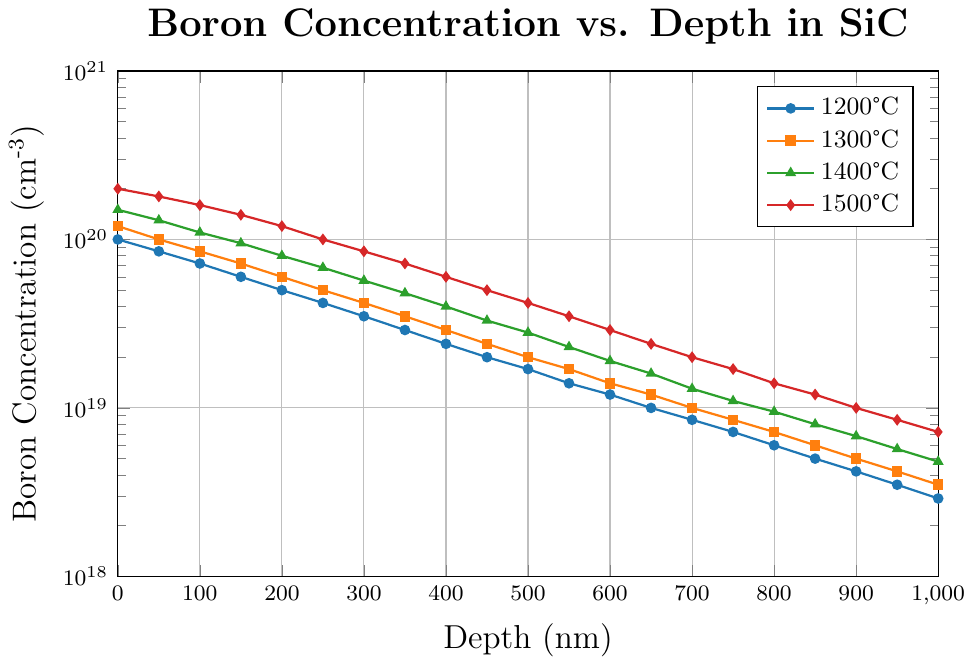What is the Boron concentration at a depth of 400 nm for the annealing temperature of 1500°C? Locate the line corresponding to 1500°C (red color). Find the point on this line at a depth of 400 nm. The Boron concentration at this point is 6.0E+19 cm\textsuperscript{-3}.
Answer: 6.0E+19 cm\textsuperscript{-3} Which annealing temperature shows the highest Boron concentration at a depth of 0 nm? Look at the starting points (depth 0 nm) of all the lines. The red line (1500°C) has the highest starting value of 2.0E+20 cm\textsuperscript{-3}.
Answer: 1500°C What is the rate of decrease in Boron concentration from 0 nm to 100 nm for the temperature 1300°C? Locate the square markers representing 1300°C line. At 0 nm, the concentration is 1.2E+20 cm\textsuperscript{-3} and at 100 nm, it is 8.5E+19 cm\textsuperscript{-3}. The rate of decrease is (1.2E+20 - 8.5E+19 cm\textsuperscript{-3}) / 100 nm.
Answer: 3.5E+18 cm\textsuperscript{-3}/nm Between 150 nm and 250 nm depths, which temperature shows the smallest decrease in Boron concentration? Calculate the difference in Boron concentration between 150 nm and 250 nm for each temperature: 1200°C (6.0E+19 - 4.2E+19), 1300°C (7.2E+19 - 5.0E+19), 1400°C (9.5E+19 - 6.8E+19), 1500°C (1.4E+20 - 1.0E+20). The smallest decrease is for 1300°C, which is 2.2E+19 cm\textsuperscript{-3}.
Answer: 1300°C What is the average Boron concentration at a depth of 600 nm across all temperatures? Sum the concentrations at 600 nm for all temperatures: 1.2E+19 (1200°C) + 1.4E+19 (1300°C) + 1.9E+19 (1400°C) + 2.9E+19 (1500°C). The sum is 7.4E+19 cm\textsuperscript{-3}. The average is 7.4E+19 / 4.
Answer: 1.85E+19 cm\textsuperscript{-3} For which temperature does Boron concentration drop below 5.0E+18 cm\textsuperscript{-3} first as depth increases? Examine the points where the Boron concentration drops below 5.0E+18 cm\textsuperscript{-3}. For 1200°C it is at 900 nm, for 1300°C at 850 nm, for 1400°C at 750 nm, and for 1500°C at 650 nm. The earliest is at 1500°C.
Answer: 1500°C What is the Boron concentration difference between 1200°C and 1500°C at a depth of 700 nm? Locate the Boron concentration at 700 nm for both 1200°C and 1500°C. The values are 8.5E+18 for 1200°C and 2.0E+19 for 1500°C. The difference is 2.0E+19 - 8.5E+18.
Answer: 1.15E+19 cm\textsuperscript{-3} 